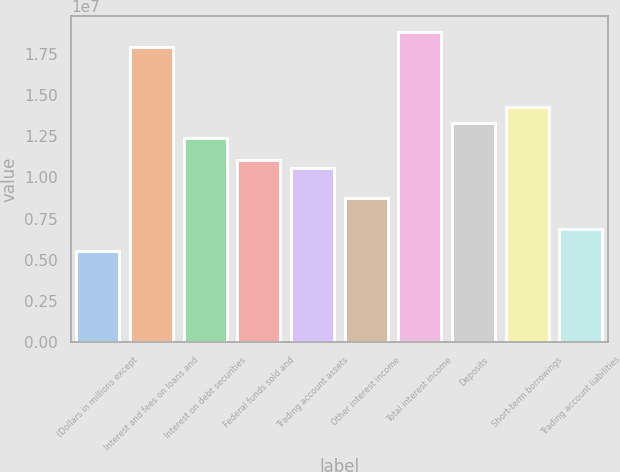Convert chart. <chart><loc_0><loc_0><loc_500><loc_500><bar_chart><fcel>(Dollars in millions except<fcel>Interest and fees on loans and<fcel>Interest on debt securities<fcel>Federal funds sold and<fcel>Trading account assets<fcel>Other interest income<fcel>Total interest income<fcel>Deposits<fcel>Short-term borrowings<fcel>Trading account liabilities<nl><fcel>5.51507e+06<fcel>1.7924e+07<fcel>1.24089e+07<fcel>1.10301e+07<fcel>1.05706e+07<fcel>8.7322e+06<fcel>1.88432e+07<fcel>1.33281e+07<fcel>1.42473e+07<fcel>6.89384e+06<nl></chart> 